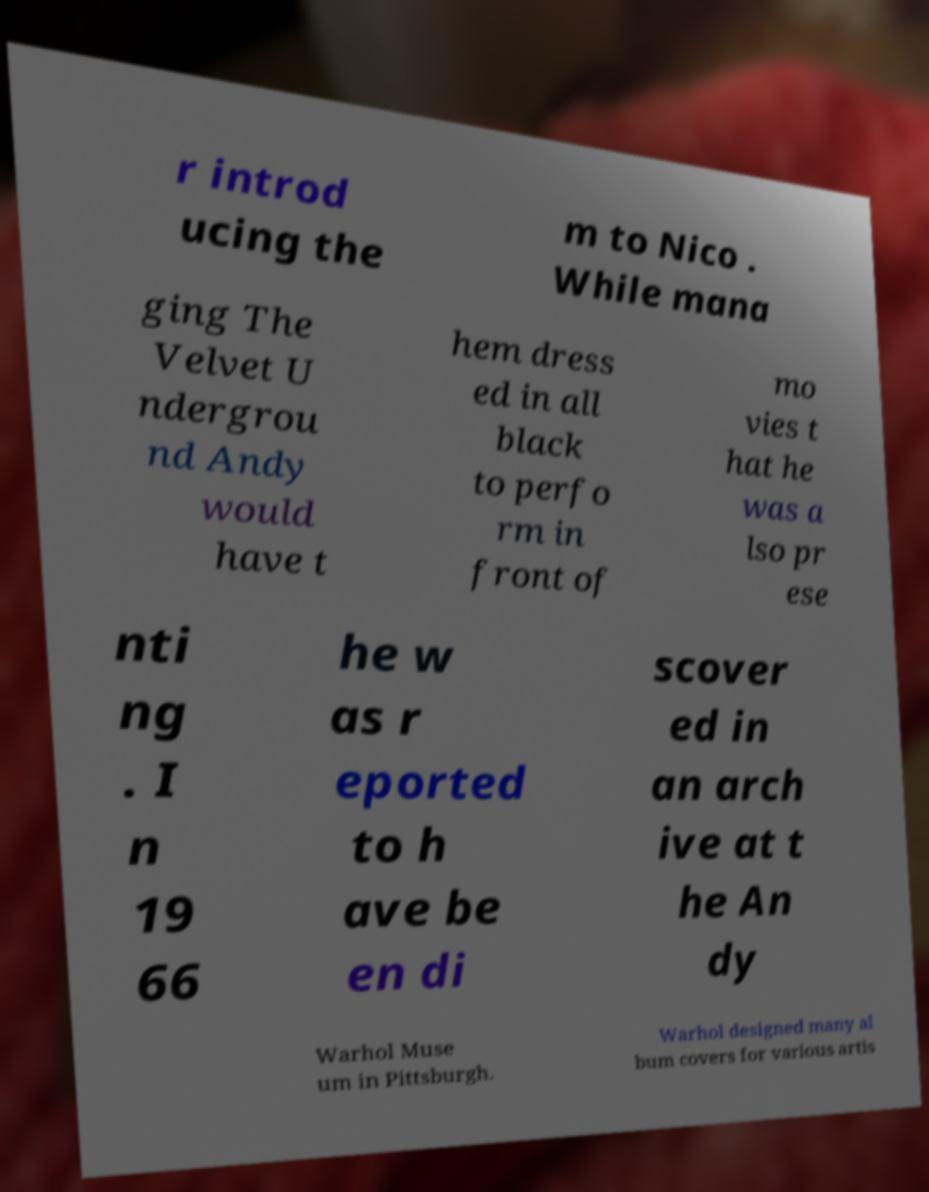For documentation purposes, I need the text within this image transcribed. Could you provide that? r introd ucing the m to Nico . While mana ging The Velvet U ndergrou nd Andy would have t hem dress ed in all black to perfo rm in front of mo vies t hat he was a lso pr ese nti ng . I n 19 66 he w as r eported to h ave be en di scover ed in an arch ive at t he An dy Warhol Muse um in Pittsburgh. Warhol designed many al bum covers for various artis 